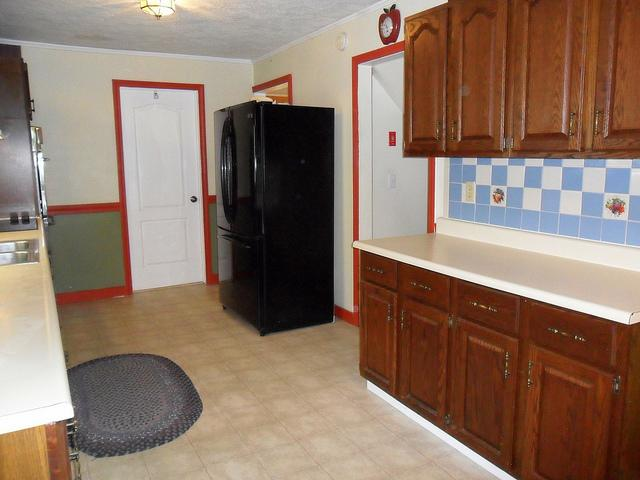What material is the floor made of?

Choices:
A) carpet
B) vinyl
C) wood
D) tile vinyl 